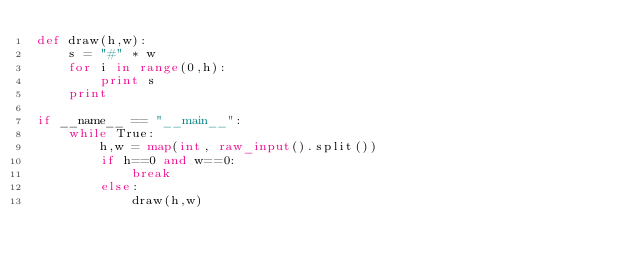<code> <loc_0><loc_0><loc_500><loc_500><_Python_>def draw(h,w):
	s = "#" * w
	for i in range(0,h):
		print s
	print

if __name__ == "__main__":
	while True:
		h,w = map(int, raw_input().split())
		if h==0 and w==0:
			break
		else:
			draw(h,w)</code> 